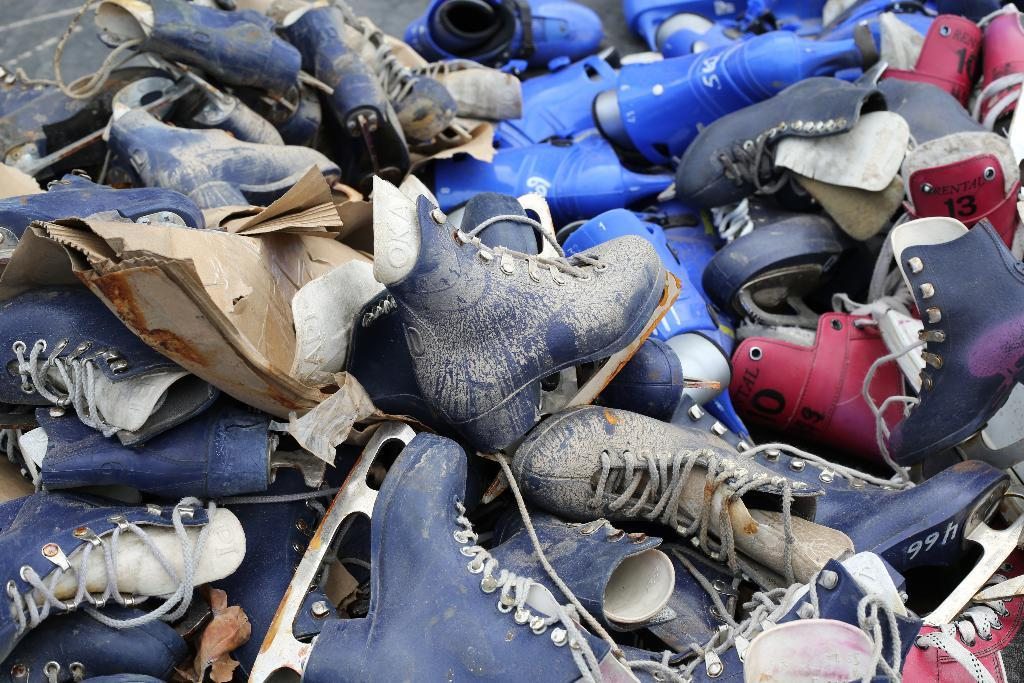What type of objects are in the image? There are different colors of shoes in the image. Where are the shoes located? The shoes are kept on the floor. How are the shoes arranged in the image? The shoes are in the middle of the image. What type of needle can be seen piercing the rail in the image? There is no needle or rail present in the image; it only features different colors of shoes. 